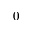Convert formula to latex. <formula><loc_0><loc_0><loc_500><loc_500>0</formula> 